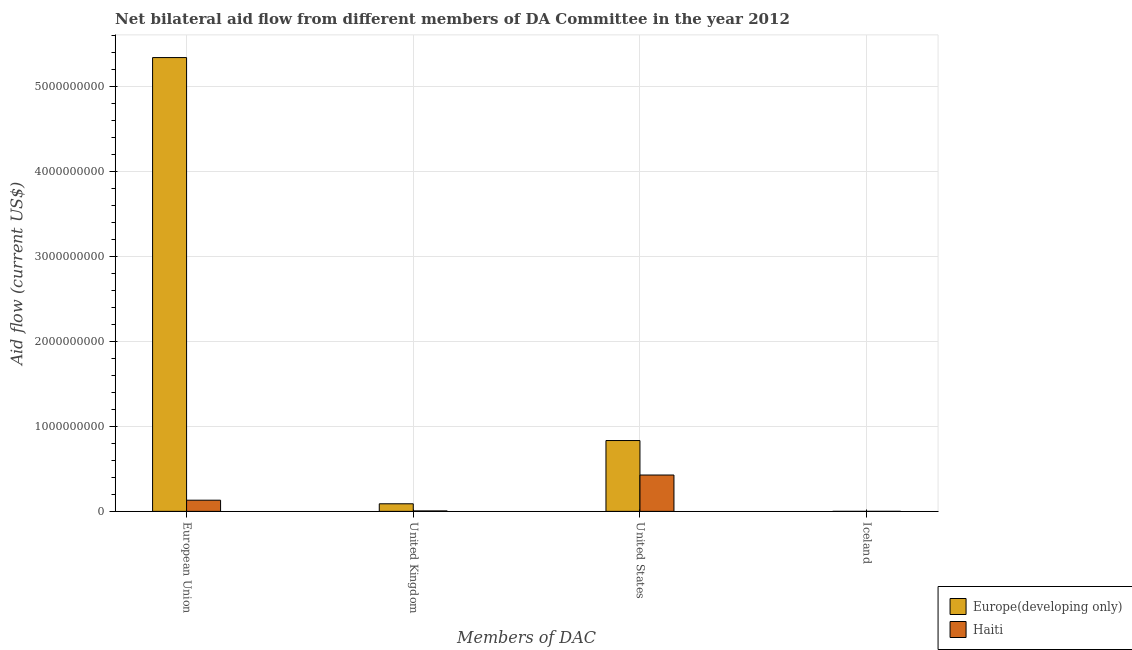Are the number of bars on each tick of the X-axis equal?
Provide a succinct answer. Yes. How many bars are there on the 1st tick from the right?
Your answer should be compact. 2. What is the label of the 3rd group of bars from the left?
Your response must be concise. United States. What is the amount of aid given by uk in Haiti?
Offer a terse response. 5.17e+06. Across all countries, what is the maximum amount of aid given by iceland?
Provide a short and direct response. 1.00e+05. Across all countries, what is the minimum amount of aid given by uk?
Your answer should be compact. 5.17e+06. In which country was the amount of aid given by iceland maximum?
Offer a very short reply. Haiti. In which country was the amount of aid given by us minimum?
Make the answer very short. Haiti. What is the total amount of aid given by us in the graph?
Make the answer very short. 1.26e+09. What is the difference between the amount of aid given by us in Europe(developing only) and that in Haiti?
Provide a short and direct response. 4.06e+08. What is the difference between the amount of aid given by eu in Haiti and the amount of aid given by us in Europe(developing only)?
Keep it short and to the point. -7.02e+08. What is the average amount of aid given by eu per country?
Provide a succinct answer. 2.74e+09. What is the difference between the amount of aid given by iceland and amount of aid given by uk in Haiti?
Offer a terse response. -5.07e+06. In how many countries, is the amount of aid given by uk greater than 200000000 US$?
Provide a short and direct response. 0. Is the amount of aid given by uk in Europe(developing only) less than that in Haiti?
Your response must be concise. No. What is the difference between the highest and the lowest amount of aid given by uk?
Make the answer very short. 8.39e+07. Is the sum of the amount of aid given by eu in Haiti and Europe(developing only) greater than the maximum amount of aid given by iceland across all countries?
Offer a very short reply. Yes. Is it the case that in every country, the sum of the amount of aid given by eu and amount of aid given by iceland is greater than the sum of amount of aid given by uk and amount of aid given by us?
Your response must be concise. Yes. What does the 1st bar from the left in United Kingdom represents?
Your answer should be very brief. Europe(developing only). What does the 2nd bar from the right in European Union represents?
Keep it short and to the point. Europe(developing only). Is it the case that in every country, the sum of the amount of aid given by eu and amount of aid given by uk is greater than the amount of aid given by us?
Ensure brevity in your answer.  No. How many bars are there?
Keep it short and to the point. 8. Are all the bars in the graph horizontal?
Ensure brevity in your answer.  No. Are the values on the major ticks of Y-axis written in scientific E-notation?
Your response must be concise. No. Does the graph contain any zero values?
Provide a succinct answer. No. Does the graph contain grids?
Offer a terse response. Yes. How many legend labels are there?
Offer a terse response. 2. How are the legend labels stacked?
Provide a short and direct response. Vertical. What is the title of the graph?
Your response must be concise. Net bilateral aid flow from different members of DA Committee in the year 2012. What is the label or title of the X-axis?
Give a very brief answer. Members of DAC. What is the label or title of the Y-axis?
Offer a very short reply. Aid flow (current US$). What is the Aid flow (current US$) of Europe(developing only) in European Union?
Offer a terse response. 5.34e+09. What is the Aid flow (current US$) of Haiti in European Union?
Make the answer very short. 1.31e+08. What is the Aid flow (current US$) of Europe(developing only) in United Kingdom?
Your answer should be very brief. 8.90e+07. What is the Aid flow (current US$) of Haiti in United Kingdom?
Provide a succinct answer. 5.17e+06. What is the Aid flow (current US$) of Europe(developing only) in United States?
Your response must be concise. 8.33e+08. What is the Aid flow (current US$) of Haiti in United States?
Your answer should be very brief. 4.28e+08. Across all Members of DAC, what is the maximum Aid flow (current US$) of Europe(developing only)?
Ensure brevity in your answer.  5.34e+09. Across all Members of DAC, what is the maximum Aid flow (current US$) of Haiti?
Make the answer very short. 4.28e+08. What is the total Aid flow (current US$) of Europe(developing only) in the graph?
Offer a terse response. 6.26e+09. What is the total Aid flow (current US$) of Haiti in the graph?
Make the answer very short. 5.64e+08. What is the difference between the Aid flow (current US$) in Europe(developing only) in European Union and that in United Kingdom?
Your answer should be very brief. 5.25e+09. What is the difference between the Aid flow (current US$) of Haiti in European Union and that in United Kingdom?
Give a very brief answer. 1.26e+08. What is the difference between the Aid flow (current US$) of Europe(developing only) in European Union and that in United States?
Provide a succinct answer. 4.51e+09. What is the difference between the Aid flow (current US$) in Haiti in European Union and that in United States?
Provide a short and direct response. -2.96e+08. What is the difference between the Aid flow (current US$) of Europe(developing only) in European Union and that in Iceland?
Ensure brevity in your answer.  5.34e+09. What is the difference between the Aid flow (current US$) of Haiti in European Union and that in Iceland?
Your answer should be compact. 1.31e+08. What is the difference between the Aid flow (current US$) of Europe(developing only) in United Kingdom and that in United States?
Provide a succinct answer. -7.44e+08. What is the difference between the Aid flow (current US$) of Haiti in United Kingdom and that in United States?
Offer a very short reply. -4.22e+08. What is the difference between the Aid flow (current US$) in Europe(developing only) in United Kingdom and that in Iceland?
Your answer should be very brief. 8.90e+07. What is the difference between the Aid flow (current US$) in Haiti in United Kingdom and that in Iceland?
Offer a very short reply. 5.07e+06. What is the difference between the Aid flow (current US$) in Europe(developing only) in United States and that in Iceland?
Provide a succinct answer. 8.33e+08. What is the difference between the Aid flow (current US$) of Haiti in United States and that in Iceland?
Ensure brevity in your answer.  4.28e+08. What is the difference between the Aid flow (current US$) of Europe(developing only) in European Union and the Aid flow (current US$) of Haiti in United Kingdom?
Provide a short and direct response. 5.33e+09. What is the difference between the Aid flow (current US$) of Europe(developing only) in European Union and the Aid flow (current US$) of Haiti in United States?
Offer a terse response. 4.91e+09. What is the difference between the Aid flow (current US$) of Europe(developing only) in European Union and the Aid flow (current US$) of Haiti in Iceland?
Offer a terse response. 5.34e+09. What is the difference between the Aid flow (current US$) of Europe(developing only) in United Kingdom and the Aid flow (current US$) of Haiti in United States?
Make the answer very short. -3.39e+08. What is the difference between the Aid flow (current US$) in Europe(developing only) in United Kingdom and the Aid flow (current US$) in Haiti in Iceland?
Offer a terse response. 8.90e+07. What is the difference between the Aid flow (current US$) of Europe(developing only) in United States and the Aid flow (current US$) of Haiti in Iceland?
Make the answer very short. 8.33e+08. What is the average Aid flow (current US$) in Europe(developing only) per Members of DAC?
Provide a succinct answer. 1.57e+09. What is the average Aid flow (current US$) of Haiti per Members of DAC?
Your answer should be very brief. 1.41e+08. What is the difference between the Aid flow (current US$) of Europe(developing only) and Aid flow (current US$) of Haiti in European Union?
Your answer should be compact. 5.21e+09. What is the difference between the Aid flow (current US$) in Europe(developing only) and Aid flow (current US$) in Haiti in United Kingdom?
Your response must be concise. 8.39e+07. What is the difference between the Aid flow (current US$) of Europe(developing only) and Aid flow (current US$) of Haiti in United States?
Your answer should be compact. 4.06e+08. What is the difference between the Aid flow (current US$) of Europe(developing only) and Aid flow (current US$) of Haiti in Iceland?
Provide a short and direct response. -8.00e+04. What is the ratio of the Aid flow (current US$) of Europe(developing only) in European Union to that in United Kingdom?
Your answer should be very brief. 59.97. What is the ratio of the Aid flow (current US$) of Haiti in European Union to that in United Kingdom?
Your response must be concise. 25.42. What is the ratio of the Aid flow (current US$) of Europe(developing only) in European Union to that in United States?
Provide a short and direct response. 6.41. What is the ratio of the Aid flow (current US$) of Haiti in European Union to that in United States?
Your answer should be compact. 0.31. What is the ratio of the Aid flow (current US$) in Europe(developing only) in European Union to that in Iceland?
Offer a very short reply. 2.67e+05. What is the ratio of the Aid flow (current US$) of Haiti in European Union to that in Iceland?
Ensure brevity in your answer.  1314.1. What is the ratio of the Aid flow (current US$) in Europe(developing only) in United Kingdom to that in United States?
Your answer should be very brief. 0.11. What is the ratio of the Aid flow (current US$) in Haiti in United Kingdom to that in United States?
Ensure brevity in your answer.  0.01. What is the ratio of the Aid flow (current US$) of Europe(developing only) in United Kingdom to that in Iceland?
Provide a short and direct response. 4452.5. What is the ratio of the Aid flow (current US$) in Haiti in United Kingdom to that in Iceland?
Keep it short and to the point. 51.7. What is the ratio of the Aid flow (current US$) of Europe(developing only) in United States to that in Iceland?
Keep it short and to the point. 4.17e+04. What is the ratio of the Aid flow (current US$) of Haiti in United States to that in Iceland?
Your response must be concise. 4276.4. What is the difference between the highest and the second highest Aid flow (current US$) in Europe(developing only)?
Make the answer very short. 4.51e+09. What is the difference between the highest and the second highest Aid flow (current US$) of Haiti?
Your response must be concise. 2.96e+08. What is the difference between the highest and the lowest Aid flow (current US$) of Europe(developing only)?
Keep it short and to the point. 5.34e+09. What is the difference between the highest and the lowest Aid flow (current US$) in Haiti?
Your answer should be very brief. 4.28e+08. 